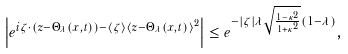Convert formula to latex. <formula><loc_0><loc_0><loc_500><loc_500>\left | e ^ { i \zeta \cdot ( z - \Theta _ { \lambda } ( x , t ) ) - \langle \zeta \rangle \langle z - \Theta _ { \lambda } ( x , t ) \rangle ^ { 2 } } \right | \leq e ^ { - | \zeta | \lambda \sqrt { \frac { 1 - \kappa ^ { 2 } } { 1 + \kappa ^ { 2 } } } ( 1 - \lambda ) } ,</formula> 